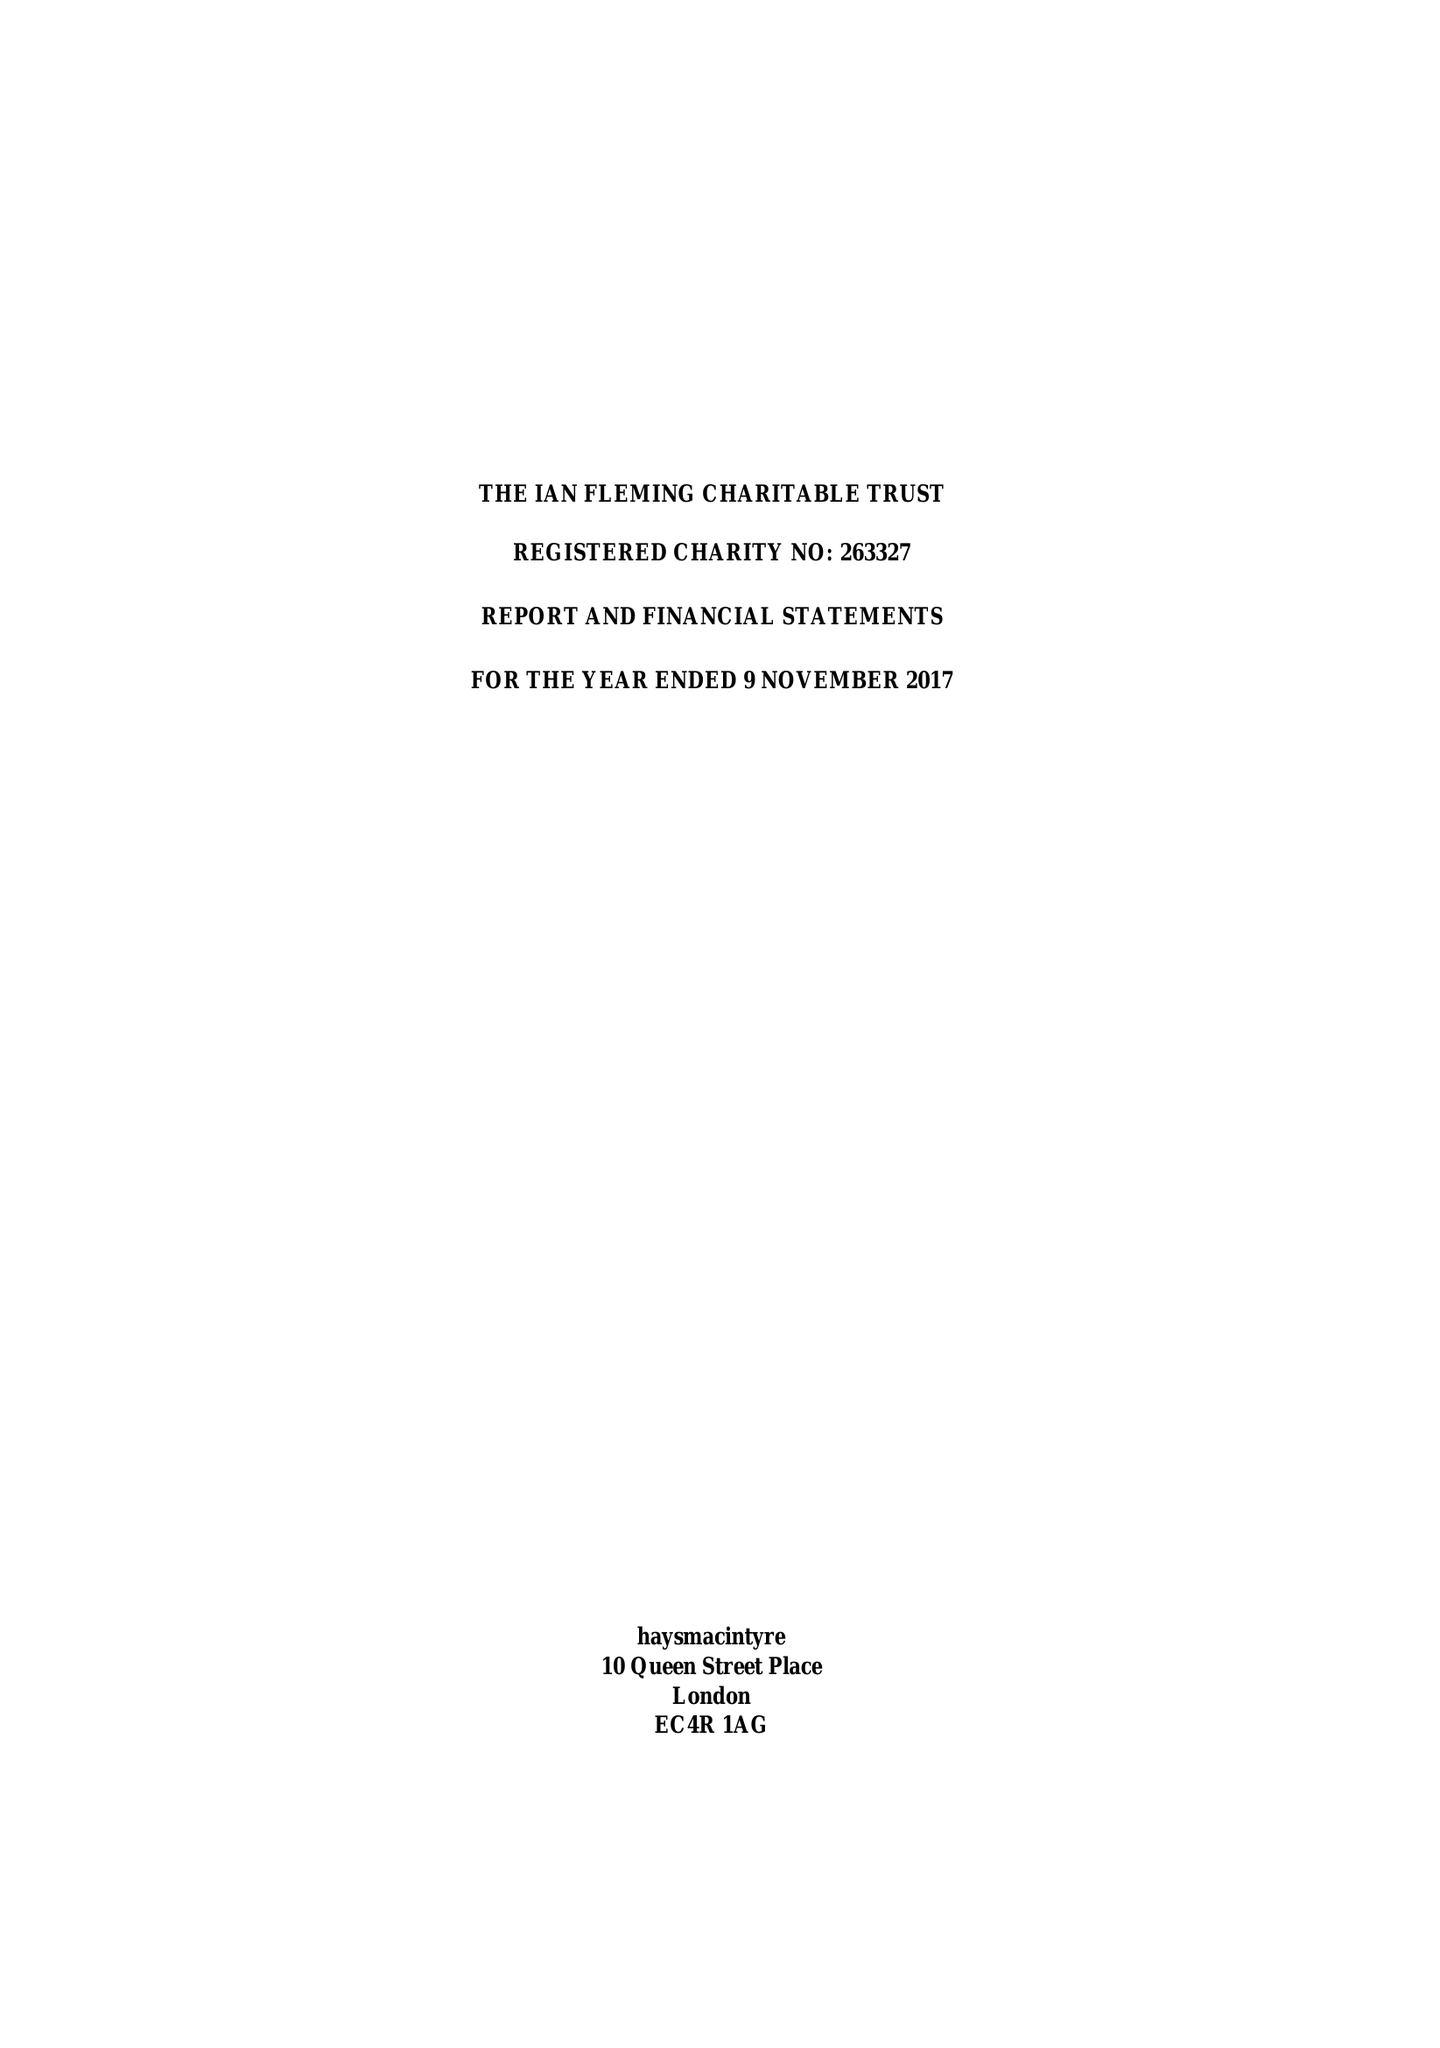What is the value for the charity_name?
Answer the question using a single word or phrase. The Ian Fleming Charitable Trust 